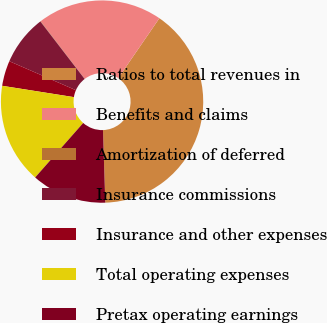<chart> <loc_0><loc_0><loc_500><loc_500><pie_chart><fcel>Ratios to total revenues in<fcel>Benefits and claims<fcel>Amortization of deferred<fcel>Insurance commissions<fcel>Insurance and other expenses<fcel>Total operating expenses<fcel>Pretax operating earnings<nl><fcel>39.9%<fcel>19.98%<fcel>0.05%<fcel>8.02%<fcel>4.04%<fcel>15.99%<fcel>12.01%<nl></chart> 